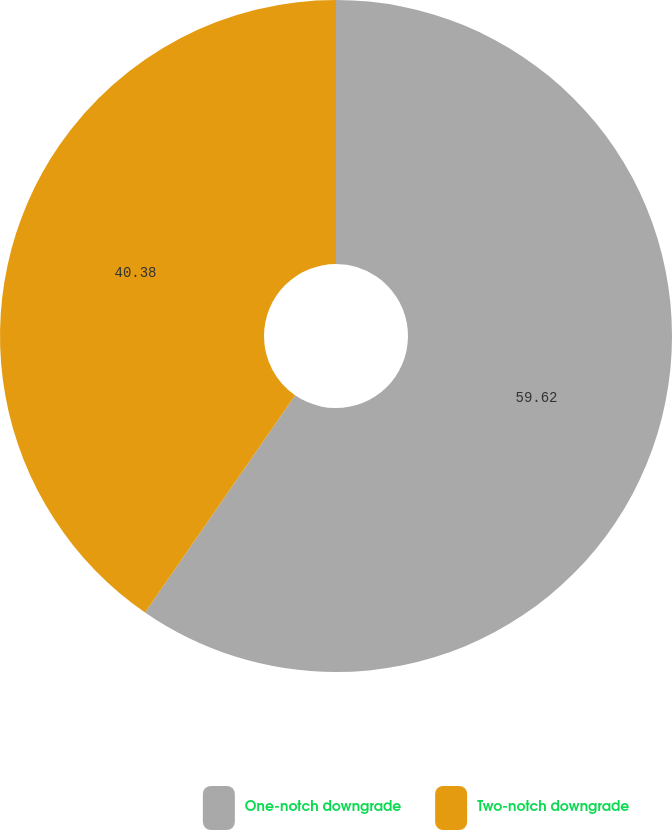<chart> <loc_0><loc_0><loc_500><loc_500><pie_chart><fcel>One-notch downgrade<fcel>Two-notch downgrade<nl><fcel>59.62%<fcel>40.38%<nl></chart> 